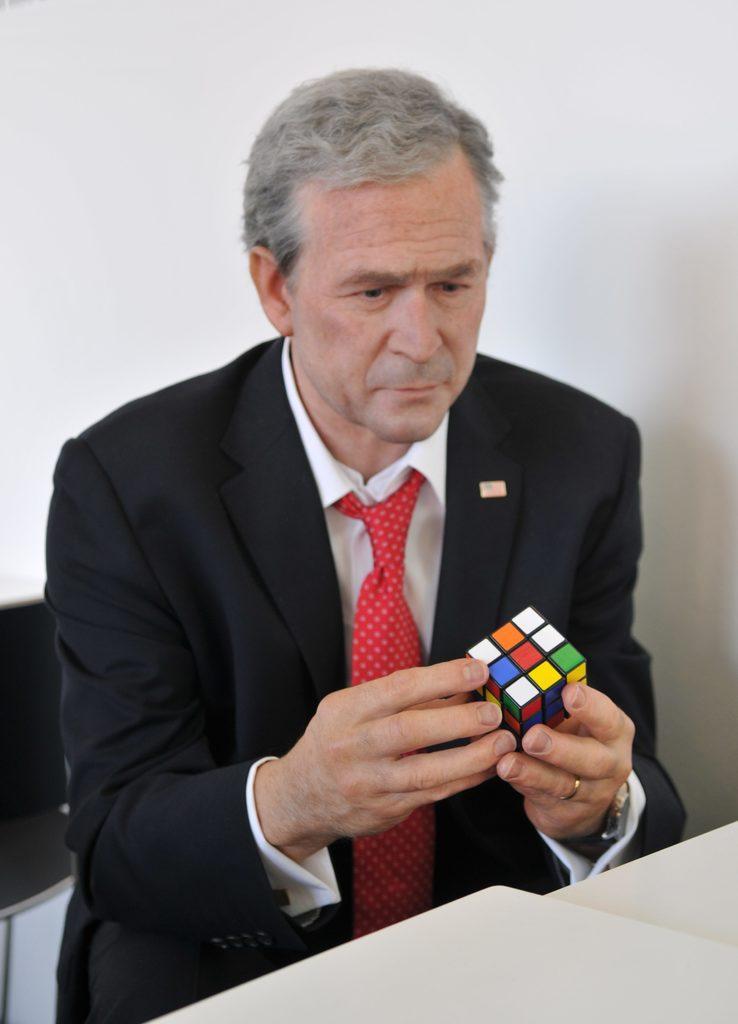How would you summarize this image in a sentence or two? In the picture there is a person sitting and playing with a cube, in front of a person there is a table, behind the person there is a wall. 